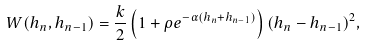Convert formula to latex. <formula><loc_0><loc_0><loc_500><loc_500>W ( h _ { n } , h _ { n - 1 } ) = \frac { k } { 2 } \left ( 1 + \rho e ^ { - \alpha ( h _ { n } + h _ { n - 1 } ) } \right ) ( h _ { n } - h _ { n - 1 } ) ^ { 2 } ,</formula> 